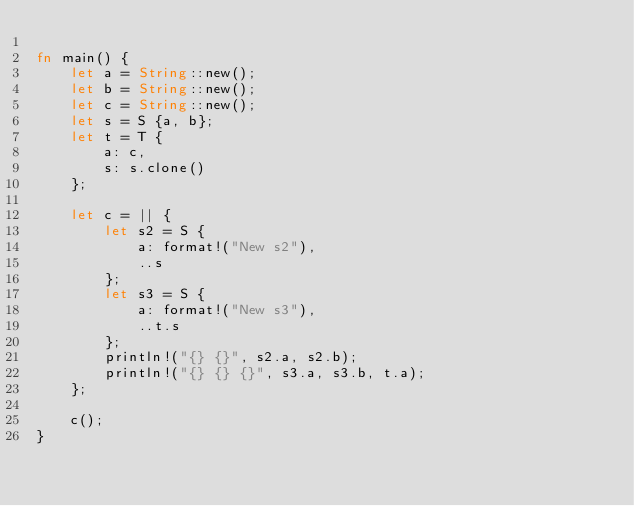<code> <loc_0><loc_0><loc_500><loc_500><_Rust_>
fn main() {
    let a = String::new();
    let b = String::new();
    let c = String::new();
    let s = S {a, b};
    let t = T {
        a: c,
        s: s.clone()
    };

    let c = || {
        let s2 = S {
            a: format!("New s2"),
            ..s
        };
        let s3 = S {
            a: format!("New s3"),
            ..t.s
        };
        println!("{} {}", s2.a, s2.b);
        println!("{} {} {}", s3.a, s3.b, t.a);
    };

    c();
}
</code> 